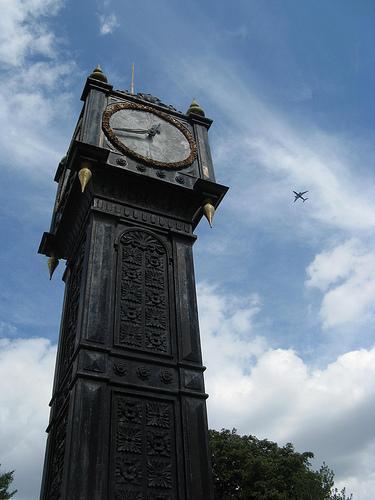How many clocks is displayed in the picture?
Give a very brief answer. 1. 